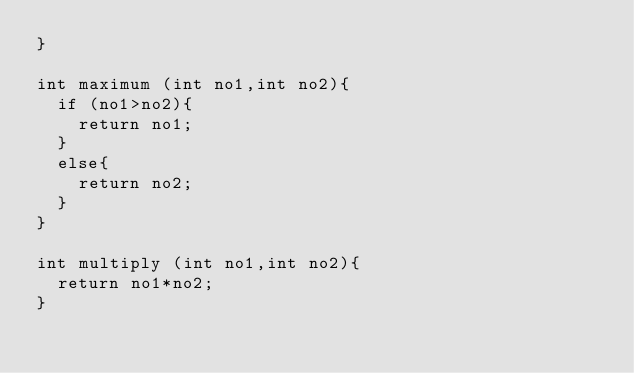Convert code to text. <code><loc_0><loc_0><loc_500><loc_500><_C_>}

int maximum (int no1,int no2){
  if (no1>no2){
    return no1;
  }
  else{
    return no2;
  }
}

int multiply (int no1,int no2){
  return no1*no2;
}</code> 